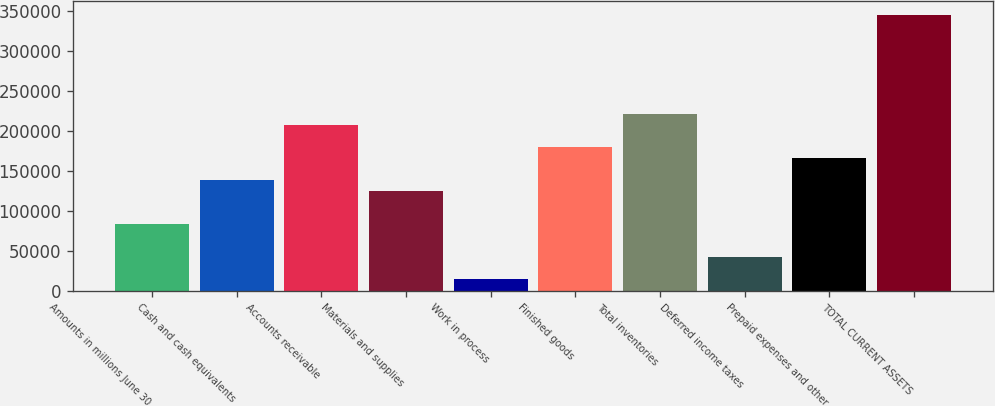Convert chart to OTSL. <chart><loc_0><loc_0><loc_500><loc_500><bar_chart><fcel>Amounts in millions June 30<fcel>Cash and cash equivalents<fcel>Accounts receivable<fcel>Materials and supplies<fcel>Work in process<fcel>Finished goods<fcel>Total inventories<fcel>Deferred income taxes<fcel>Prepaid expenses and other<fcel>TOTAL CURRENT ASSETS<nl><fcel>83156.8<fcel>138354<fcel>207350<fcel>124555<fcel>14160.3<fcel>179752<fcel>221150<fcel>41758.9<fcel>165953<fcel>345344<nl></chart> 